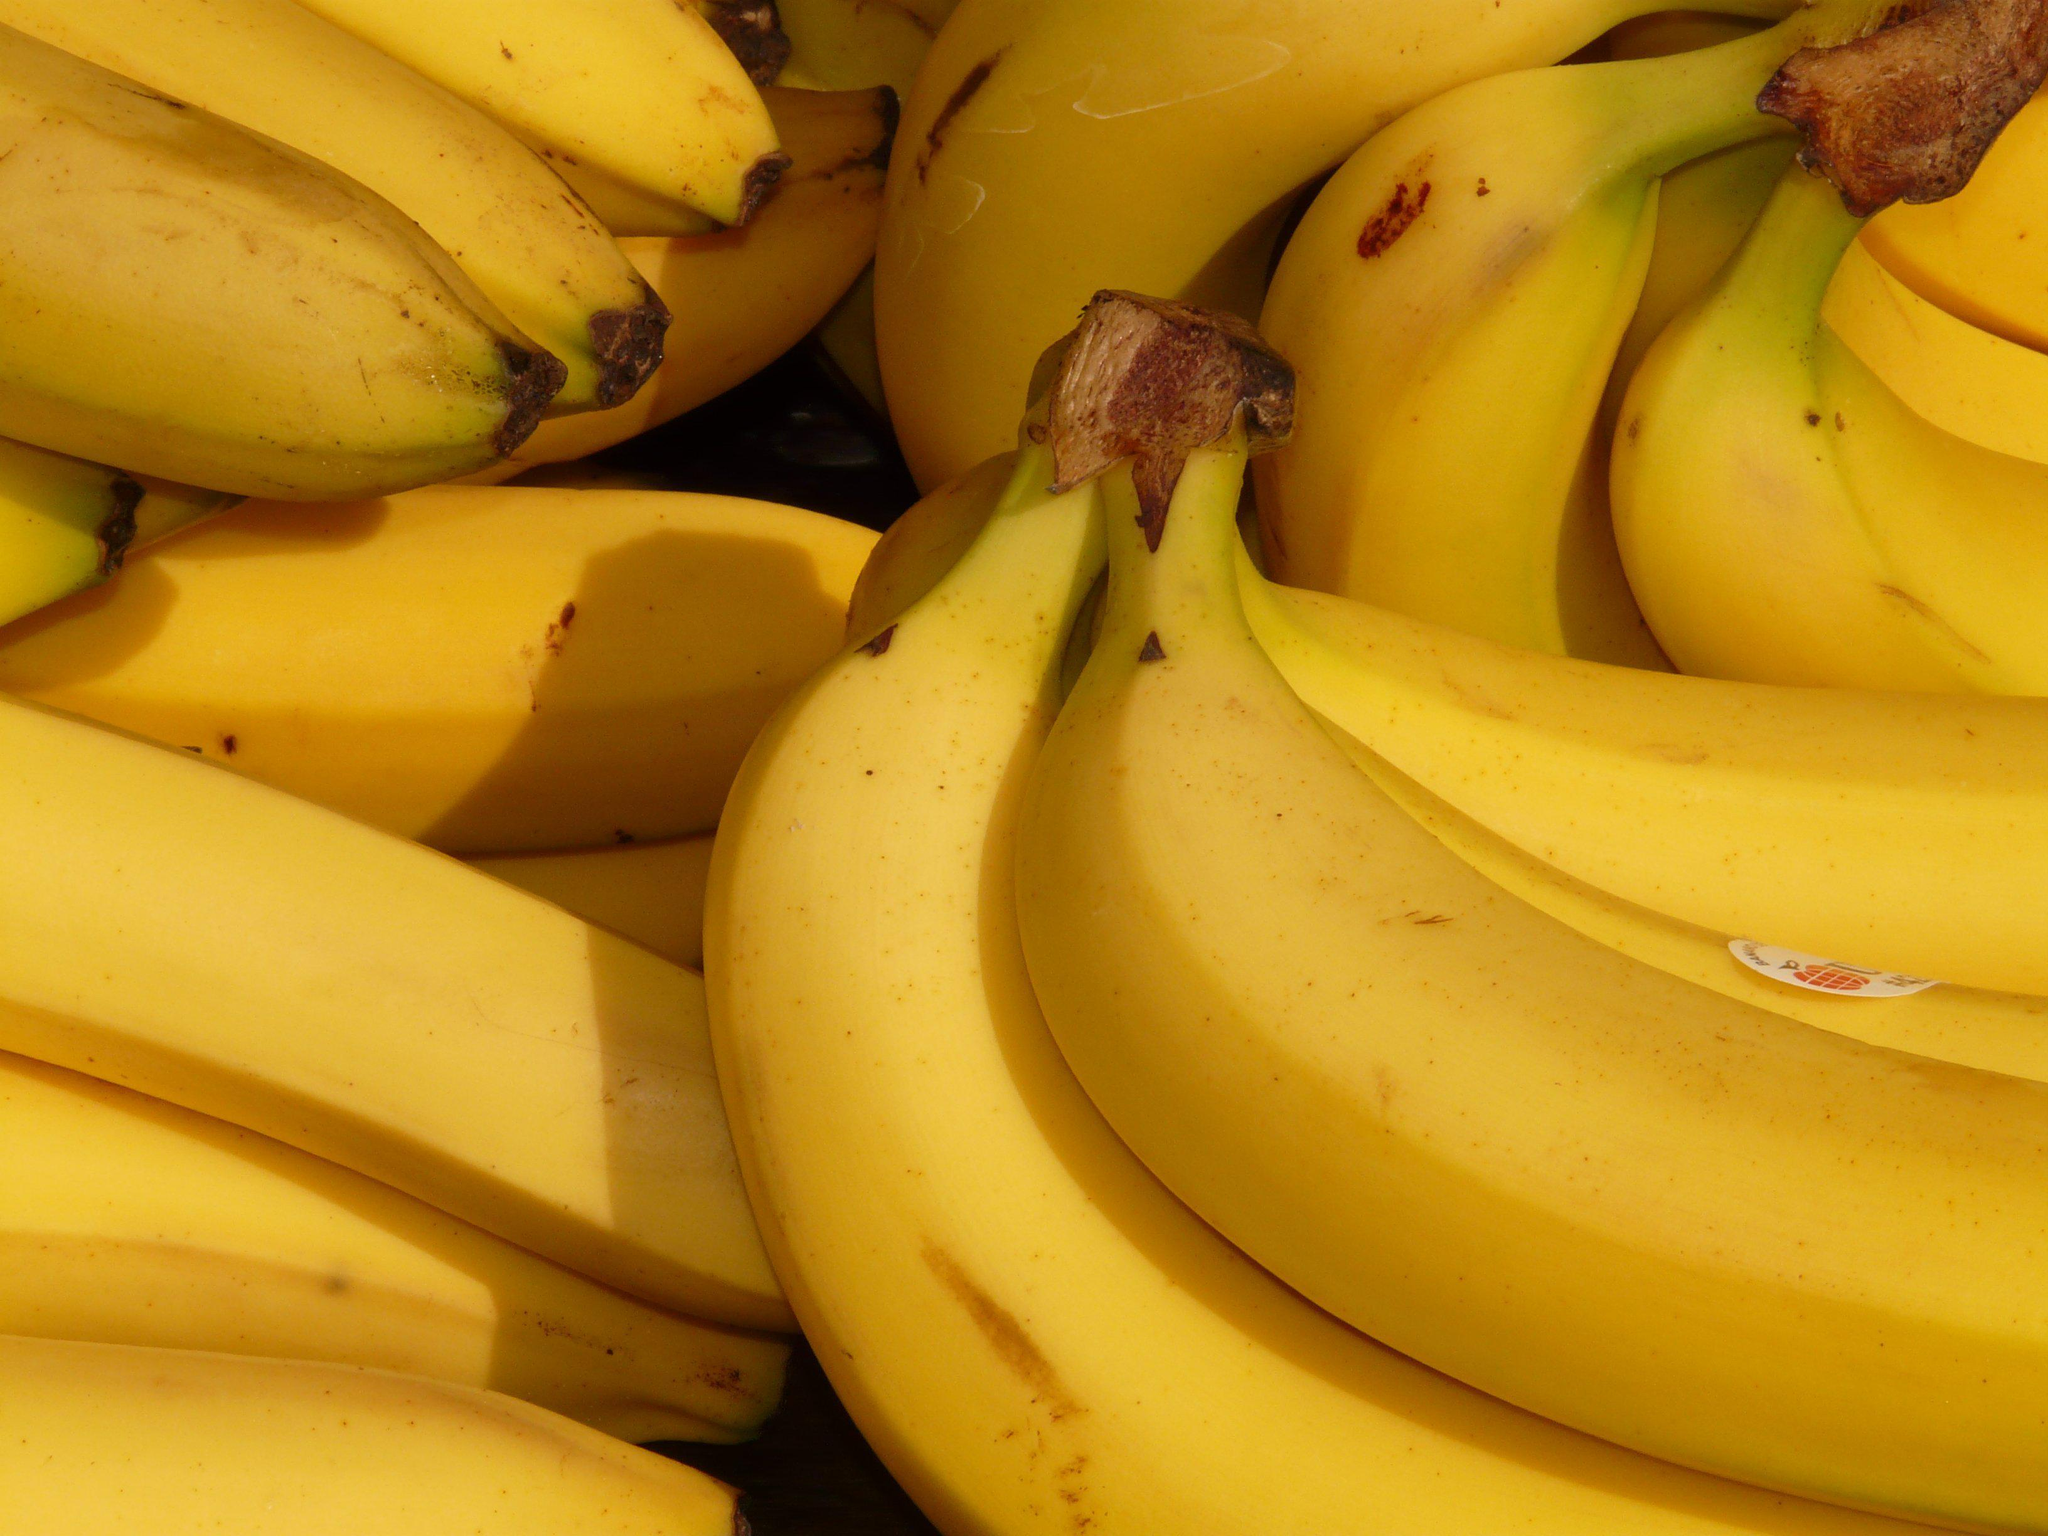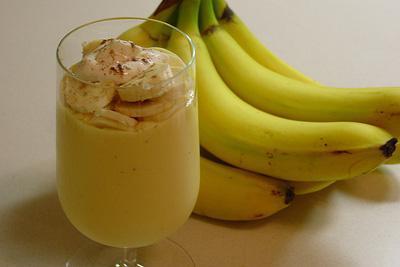The first image is the image on the left, the second image is the image on the right. Analyze the images presented: Is the assertion "A glass sits near a few bananas in one of the images." valid? Answer yes or no. Yes. The first image is the image on the left, the second image is the image on the right. Evaluate the accuracy of this statement regarding the images: "One image shows a beverage in a clear glass in front of joined bananas, and the other image contains only yellow bananas in a bunch.". Is it true? Answer yes or no. Yes. 